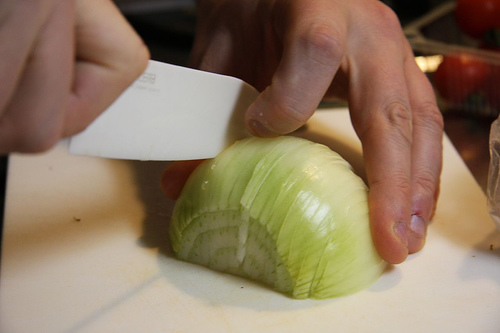<image>
Is the knife on the onion? Yes. Looking at the image, I can see the knife is positioned on top of the onion, with the onion providing support. Is there a onion on the knife? No. The onion is not positioned on the knife. They may be near each other, but the onion is not supported by or resting on top of the knife. 